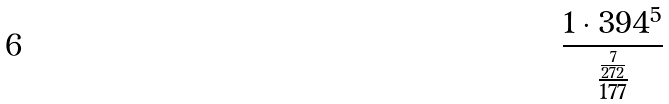Convert formula to latex. <formula><loc_0><loc_0><loc_500><loc_500>\frac { 1 \cdot 3 9 4 ^ { 5 } } { \frac { \frac { 7 } { 2 7 2 } } { 1 7 7 } }</formula> 